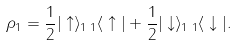<formula> <loc_0><loc_0><loc_500><loc_500>\rho _ { 1 } = \frac { 1 } { 2 } | \uparrow \rangle _ { 1 } \, { _ { 1 } \langle } \uparrow | + \frac { 1 } { 2 } | \downarrow \rangle _ { 1 } \, { _ { 1 } \langle } \downarrow | .</formula> 